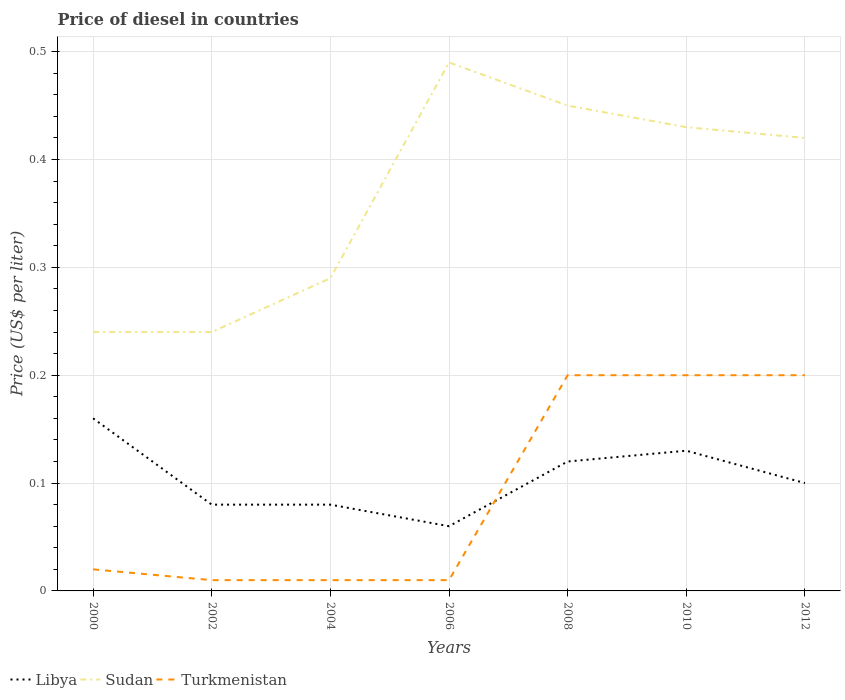Does the line corresponding to Sudan intersect with the line corresponding to Libya?
Ensure brevity in your answer.  No. In which year was the price of diesel in Turkmenistan maximum?
Ensure brevity in your answer.  2002. What is the total price of diesel in Sudan in the graph?
Ensure brevity in your answer.  -0.21. What is the difference between the highest and the second highest price of diesel in Libya?
Give a very brief answer. 0.1. Is the price of diesel in Turkmenistan strictly greater than the price of diesel in Libya over the years?
Offer a terse response. No. Does the graph contain any zero values?
Offer a very short reply. No. Does the graph contain grids?
Offer a terse response. Yes. Where does the legend appear in the graph?
Offer a very short reply. Bottom left. What is the title of the graph?
Provide a succinct answer. Price of diesel in countries. What is the label or title of the Y-axis?
Give a very brief answer. Price (US$ per liter). What is the Price (US$ per liter) of Libya in 2000?
Provide a short and direct response. 0.16. What is the Price (US$ per liter) in Sudan in 2000?
Give a very brief answer. 0.24. What is the Price (US$ per liter) of Turkmenistan in 2000?
Your answer should be compact. 0.02. What is the Price (US$ per liter) in Libya in 2002?
Your response must be concise. 0.08. What is the Price (US$ per liter) in Sudan in 2002?
Your answer should be very brief. 0.24. What is the Price (US$ per liter) in Libya in 2004?
Your answer should be compact. 0.08. What is the Price (US$ per liter) in Sudan in 2004?
Give a very brief answer. 0.29. What is the Price (US$ per liter) of Turkmenistan in 2004?
Make the answer very short. 0.01. What is the Price (US$ per liter) in Libya in 2006?
Keep it short and to the point. 0.06. What is the Price (US$ per liter) in Sudan in 2006?
Provide a short and direct response. 0.49. What is the Price (US$ per liter) of Turkmenistan in 2006?
Provide a succinct answer. 0.01. What is the Price (US$ per liter) of Libya in 2008?
Offer a terse response. 0.12. What is the Price (US$ per liter) of Sudan in 2008?
Give a very brief answer. 0.45. What is the Price (US$ per liter) of Turkmenistan in 2008?
Provide a short and direct response. 0.2. What is the Price (US$ per liter) of Libya in 2010?
Provide a succinct answer. 0.13. What is the Price (US$ per liter) in Sudan in 2010?
Offer a very short reply. 0.43. What is the Price (US$ per liter) in Turkmenistan in 2010?
Offer a very short reply. 0.2. What is the Price (US$ per liter) of Libya in 2012?
Make the answer very short. 0.1. What is the Price (US$ per liter) of Sudan in 2012?
Your answer should be very brief. 0.42. Across all years, what is the maximum Price (US$ per liter) in Libya?
Offer a terse response. 0.16. Across all years, what is the maximum Price (US$ per liter) in Sudan?
Your response must be concise. 0.49. Across all years, what is the maximum Price (US$ per liter) in Turkmenistan?
Give a very brief answer. 0.2. Across all years, what is the minimum Price (US$ per liter) in Sudan?
Your answer should be compact. 0.24. Across all years, what is the minimum Price (US$ per liter) in Turkmenistan?
Give a very brief answer. 0.01. What is the total Price (US$ per liter) of Libya in the graph?
Give a very brief answer. 0.73. What is the total Price (US$ per liter) in Sudan in the graph?
Provide a short and direct response. 2.56. What is the total Price (US$ per liter) of Turkmenistan in the graph?
Make the answer very short. 0.65. What is the difference between the Price (US$ per liter) in Libya in 2000 and that in 2002?
Make the answer very short. 0.08. What is the difference between the Price (US$ per liter) in Libya in 2000 and that in 2004?
Offer a terse response. 0.08. What is the difference between the Price (US$ per liter) in Sudan in 2000 and that in 2006?
Give a very brief answer. -0.25. What is the difference between the Price (US$ per liter) of Libya in 2000 and that in 2008?
Your answer should be compact. 0.04. What is the difference between the Price (US$ per liter) of Sudan in 2000 and that in 2008?
Make the answer very short. -0.21. What is the difference between the Price (US$ per liter) in Turkmenistan in 2000 and that in 2008?
Give a very brief answer. -0.18. What is the difference between the Price (US$ per liter) in Libya in 2000 and that in 2010?
Provide a succinct answer. 0.03. What is the difference between the Price (US$ per liter) of Sudan in 2000 and that in 2010?
Provide a short and direct response. -0.19. What is the difference between the Price (US$ per liter) of Turkmenistan in 2000 and that in 2010?
Offer a terse response. -0.18. What is the difference between the Price (US$ per liter) of Libya in 2000 and that in 2012?
Make the answer very short. 0.06. What is the difference between the Price (US$ per liter) in Sudan in 2000 and that in 2012?
Provide a short and direct response. -0.18. What is the difference between the Price (US$ per liter) in Turkmenistan in 2000 and that in 2012?
Ensure brevity in your answer.  -0.18. What is the difference between the Price (US$ per liter) of Sudan in 2002 and that in 2004?
Make the answer very short. -0.05. What is the difference between the Price (US$ per liter) in Sudan in 2002 and that in 2006?
Make the answer very short. -0.25. What is the difference between the Price (US$ per liter) in Libya in 2002 and that in 2008?
Your response must be concise. -0.04. What is the difference between the Price (US$ per liter) in Sudan in 2002 and that in 2008?
Provide a succinct answer. -0.21. What is the difference between the Price (US$ per liter) of Turkmenistan in 2002 and that in 2008?
Your response must be concise. -0.19. What is the difference between the Price (US$ per liter) of Sudan in 2002 and that in 2010?
Offer a terse response. -0.19. What is the difference between the Price (US$ per liter) in Turkmenistan in 2002 and that in 2010?
Your answer should be very brief. -0.19. What is the difference between the Price (US$ per liter) in Libya in 2002 and that in 2012?
Ensure brevity in your answer.  -0.02. What is the difference between the Price (US$ per liter) in Sudan in 2002 and that in 2012?
Your response must be concise. -0.18. What is the difference between the Price (US$ per liter) in Turkmenistan in 2002 and that in 2012?
Your answer should be very brief. -0.19. What is the difference between the Price (US$ per liter) of Sudan in 2004 and that in 2006?
Ensure brevity in your answer.  -0.2. What is the difference between the Price (US$ per liter) of Turkmenistan in 2004 and that in 2006?
Your answer should be compact. 0. What is the difference between the Price (US$ per liter) of Libya in 2004 and that in 2008?
Your answer should be compact. -0.04. What is the difference between the Price (US$ per liter) in Sudan in 2004 and that in 2008?
Provide a succinct answer. -0.16. What is the difference between the Price (US$ per liter) in Turkmenistan in 2004 and that in 2008?
Your response must be concise. -0.19. What is the difference between the Price (US$ per liter) in Libya in 2004 and that in 2010?
Make the answer very short. -0.05. What is the difference between the Price (US$ per liter) of Sudan in 2004 and that in 2010?
Give a very brief answer. -0.14. What is the difference between the Price (US$ per liter) in Turkmenistan in 2004 and that in 2010?
Give a very brief answer. -0.19. What is the difference between the Price (US$ per liter) of Libya in 2004 and that in 2012?
Offer a very short reply. -0.02. What is the difference between the Price (US$ per liter) in Sudan in 2004 and that in 2012?
Your answer should be compact. -0.13. What is the difference between the Price (US$ per liter) of Turkmenistan in 2004 and that in 2012?
Provide a succinct answer. -0.19. What is the difference between the Price (US$ per liter) in Libya in 2006 and that in 2008?
Ensure brevity in your answer.  -0.06. What is the difference between the Price (US$ per liter) of Turkmenistan in 2006 and that in 2008?
Give a very brief answer. -0.19. What is the difference between the Price (US$ per liter) in Libya in 2006 and that in 2010?
Provide a succinct answer. -0.07. What is the difference between the Price (US$ per liter) of Turkmenistan in 2006 and that in 2010?
Offer a terse response. -0.19. What is the difference between the Price (US$ per liter) in Libya in 2006 and that in 2012?
Keep it short and to the point. -0.04. What is the difference between the Price (US$ per liter) of Sudan in 2006 and that in 2012?
Make the answer very short. 0.07. What is the difference between the Price (US$ per liter) in Turkmenistan in 2006 and that in 2012?
Your response must be concise. -0.19. What is the difference between the Price (US$ per liter) in Libya in 2008 and that in 2010?
Your answer should be compact. -0.01. What is the difference between the Price (US$ per liter) in Sudan in 2008 and that in 2010?
Keep it short and to the point. 0.02. What is the difference between the Price (US$ per liter) in Turkmenistan in 2008 and that in 2010?
Give a very brief answer. 0. What is the difference between the Price (US$ per liter) of Sudan in 2008 and that in 2012?
Make the answer very short. 0.03. What is the difference between the Price (US$ per liter) of Sudan in 2010 and that in 2012?
Your answer should be very brief. 0.01. What is the difference between the Price (US$ per liter) in Libya in 2000 and the Price (US$ per liter) in Sudan in 2002?
Provide a short and direct response. -0.08. What is the difference between the Price (US$ per liter) in Sudan in 2000 and the Price (US$ per liter) in Turkmenistan in 2002?
Provide a short and direct response. 0.23. What is the difference between the Price (US$ per liter) of Libya in 2000 and the Price (US$ per liter) of Sudan in 2004?
Provide a succinct answer. -0.13. What is the difference between the Price (US$ per liter) in Sudan in 2000 and the Price (US$ per liter) in Turkmenistan in 2004?
Give a very brief answer. 0.23. What is the difference between the Price (US$ per liter) of Libya in 2000 and the Price (US$ per liter) of Sudan in 2006?
Keep it short and to the point. -0.33. What is the difference between the Price (US$ per liter) of Libya in 2000 and the Price (US$ per liter) of Turkmenistan in 2006?
Offer a very short reply. 0.15. What is the difference between the Price (US$ per liter) in Sudan in 2000 and the Price (US$ per liter) in Turkmenistan in 2006?
Offer a very short reply. 0.23. What is the difference between the Price (US$ per liter) of Libya in 2000 and the Price (US$ per liter) of Sudan in 2008?
Offer a terse response. -0.29. What is the difference between the Price (US$ per liter) in Libya in 2000 and the Price (US$ per liter) in Turkmenistan in 2008?
Keep it short and to the point. -0.04. What is the difference between the Price (US$ per liter) of Sudan in 2000 and the Price (US$ per liter) of Turkmenistan in 2008?
Offer a very short reply. 0.04. What is the difference between the Price (US$ per liter) in Libya in 2000 and the Price (US$ per liter) in Sudan in 2010?
Your response must be concise. -0.27. What is the difference between the Price (US$ per liter) of Libya in 2000 and the Price (US$ per liter) of Turkmenistan in 2010?
Give a very brief answer. -0.04. What is the difference between the Price (US$ per liter) in Sudan in 2000 and the Price (US$ per liter) in Turkmenistan in 2010?
Provide a succinct answer. 0.04. What is the difference between the Price (US$ per liter) in Libya in 2000 and the Price (US$ per liter) in Sudan in 2012?
Make the answer very short. -0.26. What is the difference between the Price (US$ per liter) in Libya in 2000 and the Price (US$ per liter) in Turkmenistan in 2012?
Keep it short and to the point. -0.04. What is the difference between the Price (US$ per liter) in Sudan in 2000 and the Price (US$ per liter) in Turkmenistan in 2012?
Offer a very short reply. 0.04. What is the difference between the Price (US$ per liter) of Libya in 2002 and the Price (US$ per liter) of Sudan in 2004?
Keep it short and to the point. -0.21. What is the difference between the Price (US$ per liter) in Libya in 2002 and the Price (US$ per liter) in Turkmenistan in 2004?
Make the answer very short. 0.07. What is the difference between the Price (US$ per liter) of Sudan in 2002 and the Price (US$ per liter) of Turkmenistan in 2004?
Give a very brief answer. 0.23. What is the difference between the Price (US$ per liter) of Libya in 2002 and the Price (US$ per liter) of Sudan in 2006?
Your answer should be very brief. -0.41. What is the difference between the Price (US$ per liter) in Libya in 2002 and the Price (US$ per liter) in Turkmenistan in 2006?
Your response must be concise. 0.07. What is the difference between the Price (US$ per liter) of Sudan in 2002 and the Price (US$ per liter) of Turkmenistan in 2006?
Offer a terse response. 0.23. What is the difference between the Price (US$ per liter) in Libya in 2002 and the Price (US$ per liter) in Sudan in 2008?
Your response must be concise. -0.37. What is the difference between the Price (US$ per liter) of Libya in 2002 and the Price (US$ per liter) of Turkmenistan in 2008?
Your answer should be compact. -0.12. What is the difference between the Price (US$ per liter) in Libya in 2002 and the Price (US$ per liter) in Sudan in 2010?
Your response must be concise. -0.35. What is the difference between the Price (US$ per liter) of Libya in 2002 and the Price (US$ per liter) of Turkmenistan in 2010?
Keep it short and to the point. -0.12. What is the difference between the Price (US$ per liter) in Libya in 2002 and the Price (US$ per liter) in Sudan in 2012?
Keep it short and to the point. -0.34. What is the difference between the Price (US$ per liter) in Libya in 2002 and the Price (US$ per liter) in Turkmenistan in 2012?
Keep it short and to the point. -0.12. What is the difference between the Price (US$ per liter) of Libya in 2004 and the Price (US$ per liter) of Sudan in 2006?
Give a very brief answer. -0.41. What is the difference between the Price (US$ per liter) of Libya in 2004 and the Price (US$ per liter) of Turkmenistan in 2006?
Ensure brevity in your answer.  0.07. What is the difference between the Price (US$ per liter) in Sudan in 2004 and the Price (US$ per liter) in Turkmenistan in 2006?
Offer a terse response. 0.28. What is the difference between the Price (US$ per liter) of Libya in 2004 and the Price (US$ per liter) of Sudan in 2008?
Keep it short and to the point. -0.37. What is the difference between the Price (US$ per liter) of Libya in 2004 and the Price (US$ per liter) of Turkmenistan in 2008?
Make the answer very short. -0.12. What is the difference between the Price (US$ per liter) in Sudan in 2004 and the Price (US$ per liter) in Turkmenistan in 2008?
Your answer should be compact. 0.09. What is the difference between the Price (US$ per liter) in Libya in 2004 and the Price (US$ per liter) in Sudan in 2010?
Keep it short and to the point. -0.35. What is the difference between the Price (US$ per liter) in Libya in 2004 and the Price (US$ per liter) in Turkmenistan in 2010?
Give a very brief answer. -0.12. What is the difference between the Price (US$ per liter) in Sudan in 2004 and the Price (US$ per liter) in Turkmenistan in 2010?
Ensure brevity in your answer.  0.09. What is the difference between the Price (US$ per liter) in Libya in 2004 and the Price (US$ per liter) in Sudan in 2012?
Provide a short and direct response. -0.34. What is the difference between the Price (US$ per liter) in Libya in 2004 and the Price (US$ per liter) in Turkmenistan in 2012?
Offer a terse response. -0.12. What is the difference between the Price (US$ per liter) in Sudan in 2004 and the Price (US$ per liter) in Turkmenistan in 2012?
Provide a short and direct response. 0.09. What is the difference between the Price (US$ per liter) of Libya in 2006 and the Price (US$ per liter) of Sudan in 2008?
Your answer should be compact. -0.39. What is the difference between the Price (US$ per liter) in Libya in 2006 and the Price (US$ per liter) in Turkmenistan in 2008?
Your answer should be very brief. -0.14. What is the difference between the Price (US$ per liter) of Sudan in 2006 and the Price (US$ per liter) of Turkmenistan in 2008?
Provide a short and direct response. 0.29. What is the difference between the Price (US$ per liter) in Libya in 2006 and the Price (US$ per liter) in Sudan in 2010?
Your answer should be very brief. -0.37. What is the difference between the Price (US$ per liter) of Libya in 2006 and the Price (US$ per liter) of Turkmenistan in 2010?
Your answer should be compact. -0.14. What is the difference between the Price (US$ per liter) of Sudan in 2006 and the Price (US$ per liter) of Turkmenistan in 2010?
Your answer should be very brief. 0.29. What is the difference between the Price (US$ per liter) of Libya in 2006 and the Price (US$ per liter) of Sudan in 2012?
Provide a succinct answer. -0.36. What is the difference between the Price (US$ per liter) in Libya in 2006 and the Price (US$ per liter) in Turkmenistan in 2012?
Your answer should be very brief. -0.14. What is the difference between the Price (US$ per liter) of Sudan in 2006 and the Price (US$ per liter) of Turkmenistan in 2012?
Ensure brevity in your answer.  0.29. What is the difference between the Price (US$ per liter) of Libya in 2008 and the Price (US$ per liter) of Sudan in 2010?
Ensure brevity in your answer.  -0.31. What is the difference between the Price (US$ per liter) in Libya in 2008 and the Price (US$ per liter) in Turkmenistan in 2010?
Your response must be concise. -0.08. What is the difference between the Price (US$ per liter) in Sudan in 2008 and the Price (US$ per liter) in Turkmenistan in 2010?
Offer a terse response. 0.25. What is the difference between the Price (US$ per liter) in Libya in 2008 and the Price (US$ per liter) in Sudan in 2012?
Offer a very short reply. -0.3. What is the difference between the Price (US$ per liter) of Libya in 2008 and the Price (US$ per liter) of Turkmenistan in 2012?
Ensure brevity in your answer.  -0.08. What is the difference between the Price (US$ per liter) of Sudan in 2008 and the Price (US$ per liter) of Turkmenistan in 2012?
Keep it short and to the point. 0.25. What is the difference between the Price (US$ per liter) in Libya in 2010 and the Price (US$ per liter) in Sudan in 2012?
Give a very brief answer. -0.29. What is the difference between the Price (US$ per liter) of Libya in 2010 and the Price (US$ per liter) of Turkmenistan in 2012?
Ensure brevity in your answer.  -0.07. What is the difference between the Price (US$ per liter) of Sudan in 2010 and the Price (US$ per liter) of Turkmenistan in 2012?
Your answer should be compact. 0.23. What is the average Price (US$ per liter) in Libya per year?
Offer a very short reply. 0.1. What is the average Price (US$ per liter) of Sudan per year?
Ensure brevity in your answer.  0.37. What is the average Price (US$ per liter) in Turkmenistan per year?
Offer a very short reply. 0.09. In the year 2000, what is the difference between the Price (US$ per liter) in Libya and Price (US$ per liter) in Sudan?
Offer a very short reply. -0.08. In the year 2000, what is the difference between the Price (US$ per liter) of Libya and Price (US$ per liter) of Turkmenistan?
Provide a short and direct response. 0.14. In the year 2000, what is the difference between the Price (US$ per liter) of Sudan and Price (US$ per liter) of Turkmenistan?
Offer a terse response. 0.22. In the year 2002, what is the difference between the Price (US$ per liter) of Libya and Price (US$ per liter) of Sudan?
Keep it short and to the point. -0.16. In the year 2002, what is the difference between the Price (US$ per liter) of Libya and Price (US$ per liter) of Turkmenistan?
Your response must be concise. 0.07. In the year 2002, what is the difference between the Price (US$ per liter) in Sudan and Price (US$ per liter) in Turkmenistan?
Your response must be concise. 0.23. In the year 2004, what is the difference between the Price (US$ per liter) of Libya and Price (US$ per liter) of Sudan?
Ensure brevity in your answer.  -0.21. In the year 2004, what is the difference between the Price (US$ per liter) in Libya and Price (US$ per liter) in Turkmenistan?
Your answer should be compact. 0.07. In the year 2004, what is the difference between the Price (US$ per liter) in Sudan and Price (US$ per liter) in Turkmenistan?
Your answer should be compact. 0.28. In the year 2006, what is the difference between the Price (US$ per liter) in Libya and Price (US$ per liter) in Sudan?
Offer a very short reply. -0.43. In the year 2006, what is the difference between the Price (US$ per liter) in Libya and Price (US$ per liter) in Turkmenistan?
Offer a very short reply. 0.05. In the year 2006, what is the difference between the Price (US$ per liter) in Sudan and Price (US$ per liter) in Turkmenistan?
Your response must be concise. 0.48. In the year 2008, what is the difference between the Price (US$ per liter) of Libya and Price (US$ per liter) of Sudan?
Ensure brevity in your answer.  -0.33. In the year 2008, what is the difference between the Price (US$ per liter) of Libya and Price (US$ per liter) of Turkmenistan?
Make the answer very short. -0.08. In the year 2008, what is the difference between the Price (US$ per liter) of Sudan and Price (US$ per liter) of Turkmenistan?
Provide a short and direct response. 0.25. In the year 2010, what is the difference between the Price (US$ per liter) in Libya and Price (US$ per liter) in Sudan?
Keep it short and to the point. -0.3. In the year 2010, what is the difference between the Price (US$ per liter) of Libya and Price (US$ per liter) of Turkmenistan?
Provide a succinct answer. -0.07. In the year 2010, what is the difference between the Price (US$ per liter) of Sudan and Price (US$ per liter) of Turkmenistan?
Your response must be concise. 0.23. In the year 2012, what is the difference between the Price (US$ per liter) of Libya and Price (US$ per liter) of Sudan?
Give a very brief answer. -0.32. In the year 2012, what is the difference between the Price (US$ per liter) of Sudan and Price (US$ per liter) of Turkmenistan?
Offer a very short reply. 0.22. What is the ratio of the Price (US$ per liter) in Sudan in 2000 to that in 2002?
Ensure brevity in your answer.  1. What is the ratio of the Price (US$ per liter) of Turkmenistan in 2000 to that in 2002?
Ensure brevity in your answer.  2. What is the ratio of the Price (US$ per liter) of Libya in 2000 to that in 2004?
Keep it short and to the point. 2. What is the ratio of the Price (US$ per liter) of Sudan in 2000 to that in 2004?
Your answer should be very brief. 0.83. What is the ratio of the Price (US$ per liter) of Libya in 2000 to that in 2006?
Offer a very short reply. 2.67. What is the ratio of the Price (US$ per liter) of Sudan in 2000 to that in 2006?
Keep it short and to the point. 0.49. What is the ratio of the Price (US$ per liter) of Turkmenistan in 2000 to that in 2006?
Your answer should be compact. 2. What is the ratio of the Price (US$ per liter) of Libya in 2000 to that in 2008?
Give a very brief answer. 1.33. What is the ratio of the Price (US$ per liter) in Sudan in 2000 to that in 2008?
Make the answer very short. 0.53. What is the ratio of the Price (US$ per liter) in Libya in 2000 to that in 2010?
Offer a very short reply. 1.23. What is the ratio of the Price (US$ per liter) of Sudan in 2000 to that in 2010?
Your answer should be compact. 0.56. What is the ratio of the Price (US$ per liter) of Turkmenistan in 2000 to that in 2010?
Your answer should be compact. 0.1. What is the ratio of the Price (US$ per liter) of Turkmenistan in 2000 to that in 2012?
Provide a succinct answer. 0.1. What is the ratio of the Price (US$ per liter) in Libya in 2002 to that in 2004?
Provide a succinct answer. 1. What is the ratio of the Price (US$ per liter) of Sudan in 2002 to that in 2004?
Your answer should be very brief. 0.83. What is the ratio of the Price (US$ per liter) of Libya in 2002 to that in 2006?
Give a very brief answer. 1.33. What is the ratio of the Price (US$ per liter) in Sudan in 2002 to that in 2006?
Offer a very short reply. 0.49. What is the ratio of the Price (US$ per liter) of Turkmenistan in 2002 to that in 2006?
Provide a succinct answer. 1. What is the ratio of the Price (US$ per liter) in Libya in 2002 to that in 2008?
Offer a terse response. 0.67. What is the ratio of the Price (US$ per liter) in Sudan in 2002 to that in 2008?
Give a very brief answer. 0.53. What is the ratio of the Price (US$ per liter) in Libya in 2002 to that in 2010?
Provide a short and direct response. 0.62. What is the ratio of the Price (US$ per liter) in Sudan in 2002 to that in 2010?
Your answer should be compact. 0.56. What is the ratio of the Price (US$ per liter) of Turkmenistan in 2002 to that in 2010?
Your answer should be compact. 0.05. What is the ratio of the Price (US$ per liter) in Libya in 2002 to that in 2012?
Keep it short and to the point. 0.8. What is the ratio of the Price (US$ per liter) in Sudan in 2004 to that in 2006?
Give a very brief answer. 0.59. What is the ratio of the Price (US$ per liter) of Turkmenistan in 2004 to that in 2006?
Provide a succinct answer. 1. What is the ratio of the Price (US$ per liter) in Libya in 2004 to that in 2008?
Your answer should be compact. 0.67. What is the ratio of the Price (US$ per liter) in Sudan in 2004 to that in 2008?
Your answer should be very brief. 0.64. What is the ratio of the Price (US$ per liter) in Libya in 2004 to that in 2010?
Make the answer very short. 0.62. What is the ratio of the Price (US$ per liter) of Sudan in 2004 to that in 2010?
Your response must be concise. 0.67. What is the ratio of the Price (US$ per liter) of Sudan in 2004 to that in 2012?
Give a very brief answer. 0.69. What is the ratio of the Price (US$ per liter) in Turkmenistan in 2004 to that in 2012?
Provide a succinct answer. 0.05. What is the ratio of the Price (US$ per liter) of Libya in 2006 to that in 2008?
Your answer should be very brief. 0.5. What is the ratio of the Price (US$ per liter) in Sudan in 2006 to that in 2008?
Provide a succinct answer. 1.09. What is the ratio of the Price (US$ per liter) of Libya in 2006 to that in 2010?
Keep it short and to the point. 0.46. What is the ratio of the Price (US$ per liter) of Sudan in 2006 to that in 2010?
Make the answer very short. 1.14. What is the ratio of the Price (US$ per liter) of Turkmenistan in 2006 to that in 2010?
Your answer should be very brief. 0.05. What is the ratio of the Price (US$ per liter) in Turkmenistan in 2006 to that in 2012?
Provide a short and direct response. 0.05. What is the ratio of the Price (US$ per liter) in Sudan in 2008 to that in 2010?
Keep it short and to the point. 1.05. What is the ratio of the Price (US$ per liter) in Sudan in 2008 to that in 2012?
Keep it short and to the point. 1.07. What is the ratio of the Price (US$ per liter) of Turkmenistan in 2008 to that in 2012?
Offer a terse response. 1. What is the ratio of the Price (US$ per liter) in Sudan in 2010 to that in 2012?
Your answer should be very brief. 1.02. What is the ratio of the Price (US$ per liter) in Turkmenistan in 2010 to that in 2012?
Ensure brevity in your answer.  1. What is the difference between the highest and the second highest Price (US$ per liter) in Libya?
Your answer should be very brief. 0.03. What is the difference between the highest and the second highest Price (US$ per liter) in Sudan?
Your answer should be very brief. 0.04. What is the difference between the highest and the lowest Price (US$ per liter) in Turkmenistan?
Your answer should be compact. 0.19. 